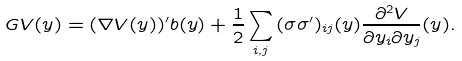<formula> <loc_0><loc_0><loc_500><loc_500>G V ( y ) = ( \nabla V ( y ) ) ^ { \prime } b ( y ) + \frac { 1 } { 2 } \sum _ { i , j } { ( \sigma \sigma ^ { \prime } ) _ { i j } ( y ) \frac { \partial ^ { 2 } V } { \partial y _ { i } \partial y _ { j } } } ( y ) .</formula> 